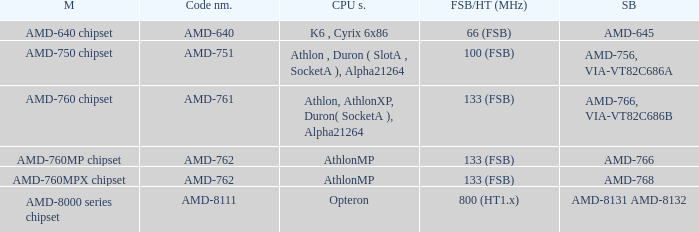What shows for Southbridge when the Model number is amd-640 chipset? AMD-645. 